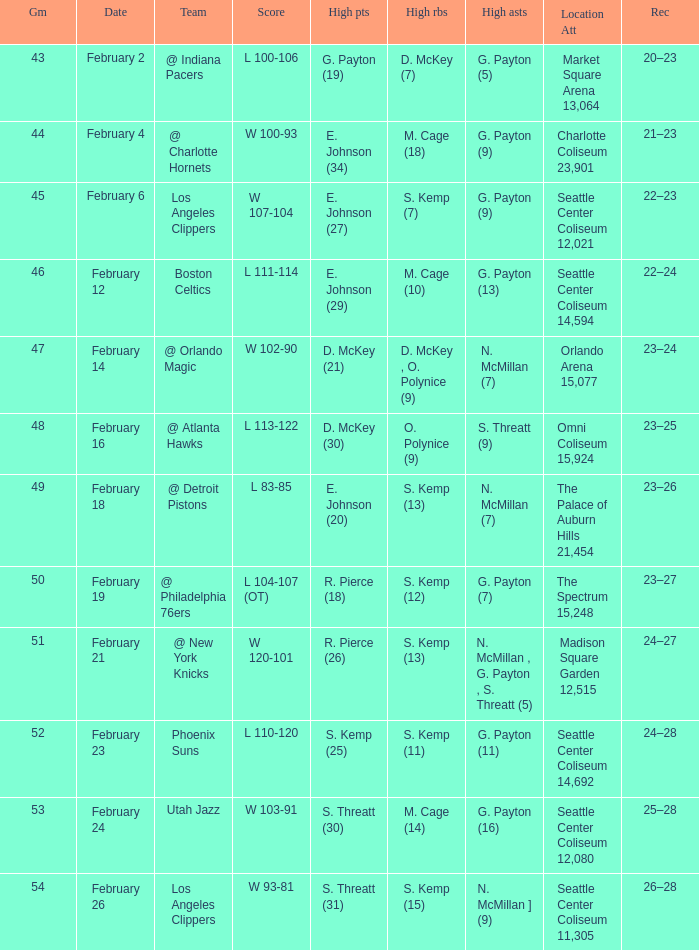What is the record for the Utah Jazz? 25–28. 